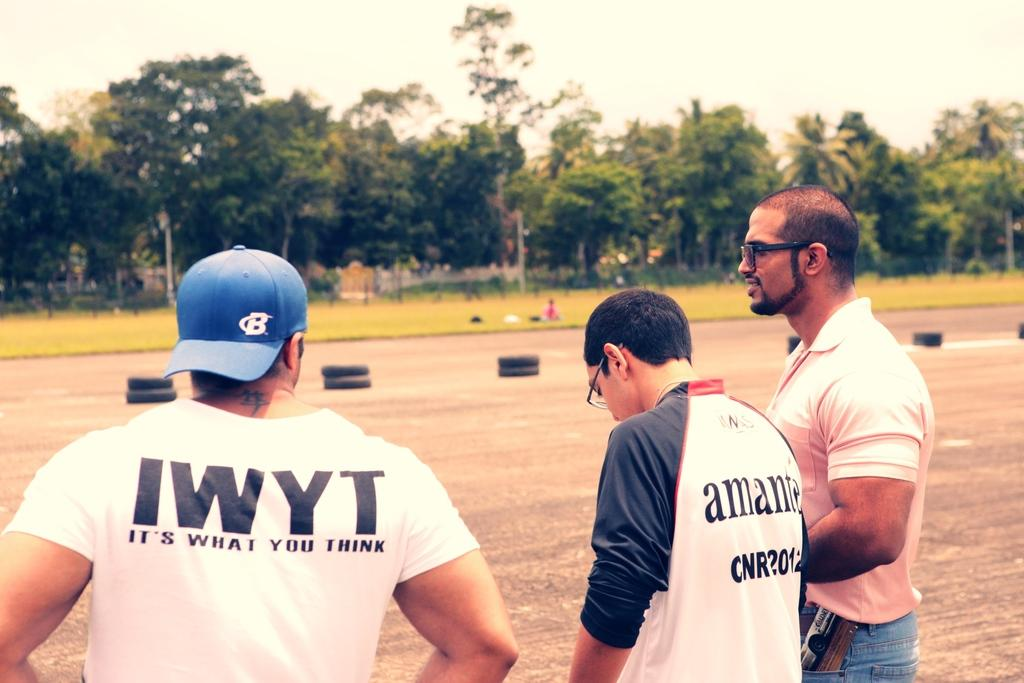Provide a one-sentence caption for the provided image. IWYT is short for It's What You Think!. 